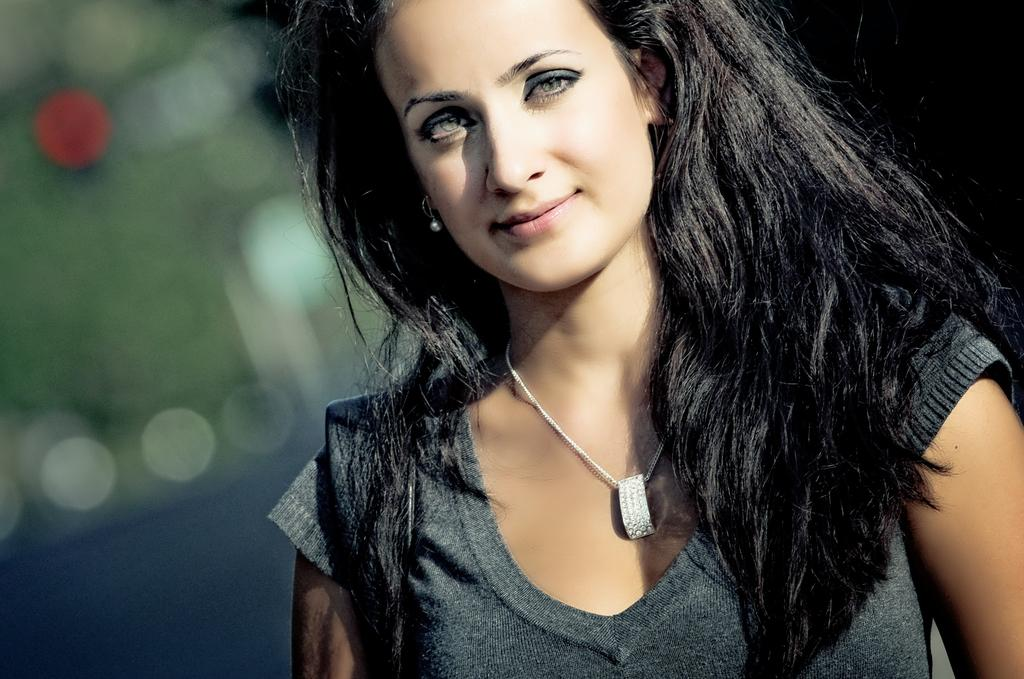Who is the main subject in the image? There is a woman in the image. What is the woman's facial expression? The woman is smiling. What accessory is the woman wearing? The woman is wearing a chain with a locket. Can you describe the background of the image? The background of the image is blurry. How does the woman cry in the image? The woman is not crying in the image; she is smiling. What type of treatment is the woman receiving in the image? There is no indication in the image that the woman is receiving any treatment. 